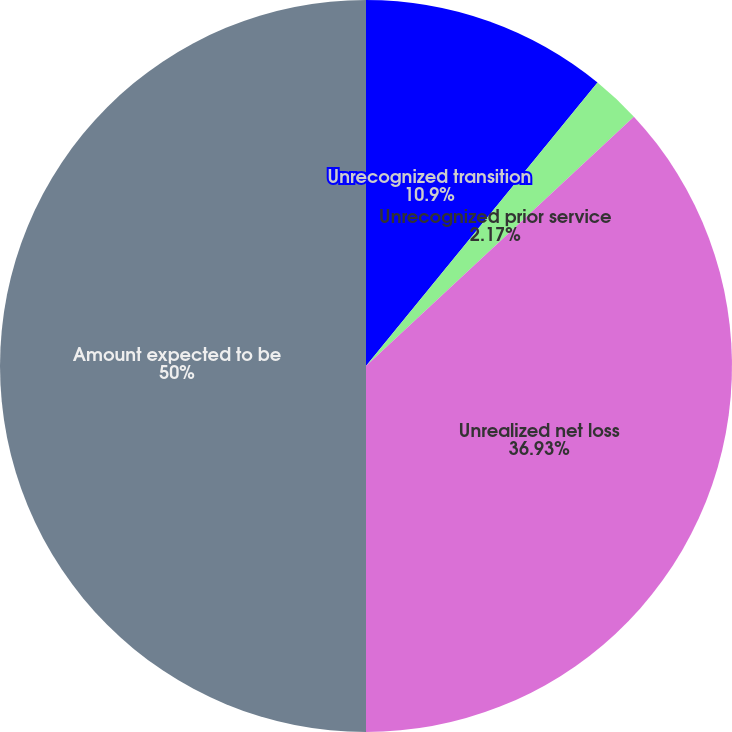Convert chart. <chart><loc_0><loc_0><loc_500><loc_500><pie_chart><fcel>Unrecognized transition<fcel>Unrecognized prior service<fcel>Unrealized net loss<fcel>Amount expected to be<nl><fcel>10.9%<fcel>2.17%<fcel>36.93%<fcel>50.0%<nl></chart> 